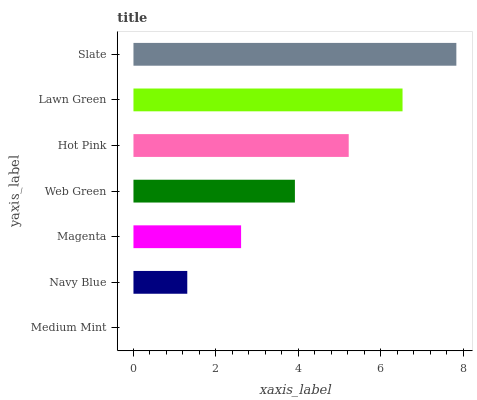Is Medium Mint the minimum?
Answer yes or no. Yes. Is Slate the maximum?
Answer yes or no. Yes. Is Navy Blue the minimum?
Answer yes or no. No. Is Navy Blue the maximum?
Answer yes or no. No. Is Navy Blue greater than Medium Mint?
Answer yes or no. Yes. Is Medium Mint less than Navy Blue?
Answer yes or no. Yes. Is Medium Mint greater than Navy Blue?
Answer yes or no. No. Is Navy Blue less than Medium Mint?
Answer yes or no. No. Is Web Green the high median?
Answer yes or no. Yes. Is Web Green the low median?
Answer yes or no. Yes. Is Medium Mint the high median?
Answer yes or no. No. Is Navy Blue the low median?
Answer yes or no. No. 